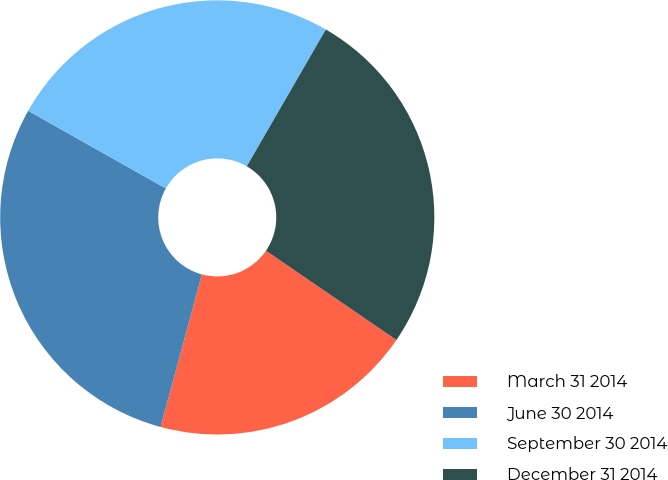<chart> <loc_0><loc_0><loc_500><loc_500><pie_chart><fcel>March 31 2014<fcel>June 30 2014<fcel>September 30 2014<fcel>December 31 2014<nl><fcel>19.66%<fcel>28.97%<fcel>25.17%<fcel>26.21%<nl></chart> 